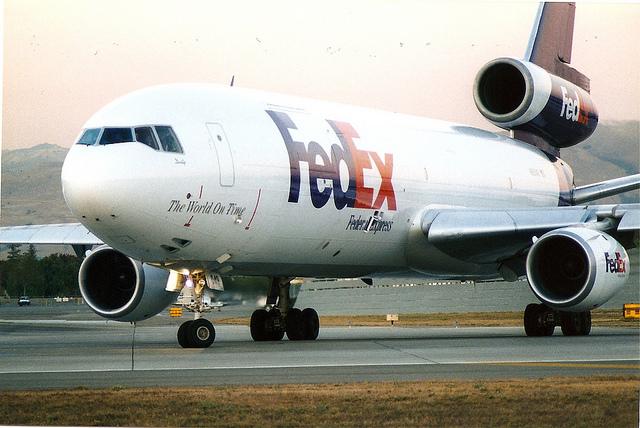Will the plane be delivering cargo or passengers?
Quick response, please. Cargo. What company own this airplane?
Short answer required. Fedex. How many engines can be seen at this angle?
Concise answer only. 3. 